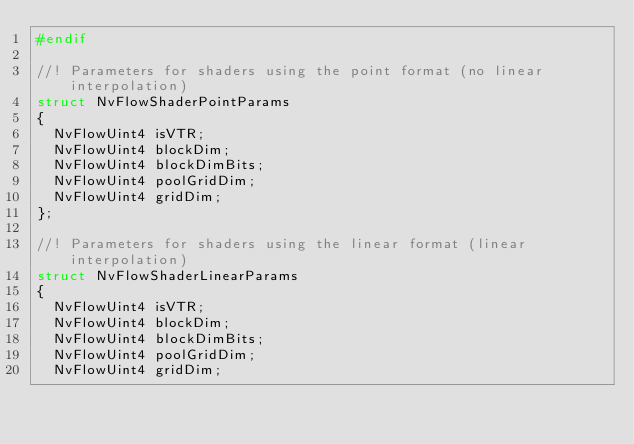Convert code to text. <code><loc_0><loc_0><loc_500><loc_500><_C_>#endif

//! Parameters for shaders using the point format (no linear interpolation)
struct NvFlowShaderPointParams
{
	NvFlowUint4 isVTR;
	NvFlowUint4 blockDim;
	NvFlowUint4 blockDimBits;
	NvFlowUint4 poolGridDim;
	NvFlowUint4 gridDim;
};

//! Parameters for shaders using the linear format (linear interpolation)
struct NvFlowShaderLinearParams
{
	NvFlowUint4 isVTR;
	NvFlowUint4 blockDim;
	NvFlowUint4 blockDimBits;
	NvFlowUint4 poolGridDim;
	NvFlowUint4 gridDim;
</code> 